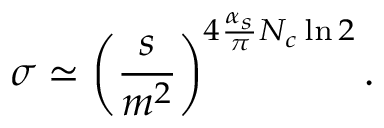<formula> <loc_0><loc_0><loc_500><loc_500>\sigma \simeq \left ( { \frac { s } { m ^ { 2 } } } \right ) ^ { 4 { \frac { \alpha _ { s } } { \pi } } N _ { c } \ln 2 } .</formula> 